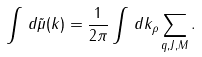<formula> <loc_0><loc_0><loc_500><loc_500>\int \, d \tilde { \mu } ( k ) = \frac { 1 } { 2 \pi } \int \, d k _ { \rho } \sum _ { q , J , M } .</formula> 